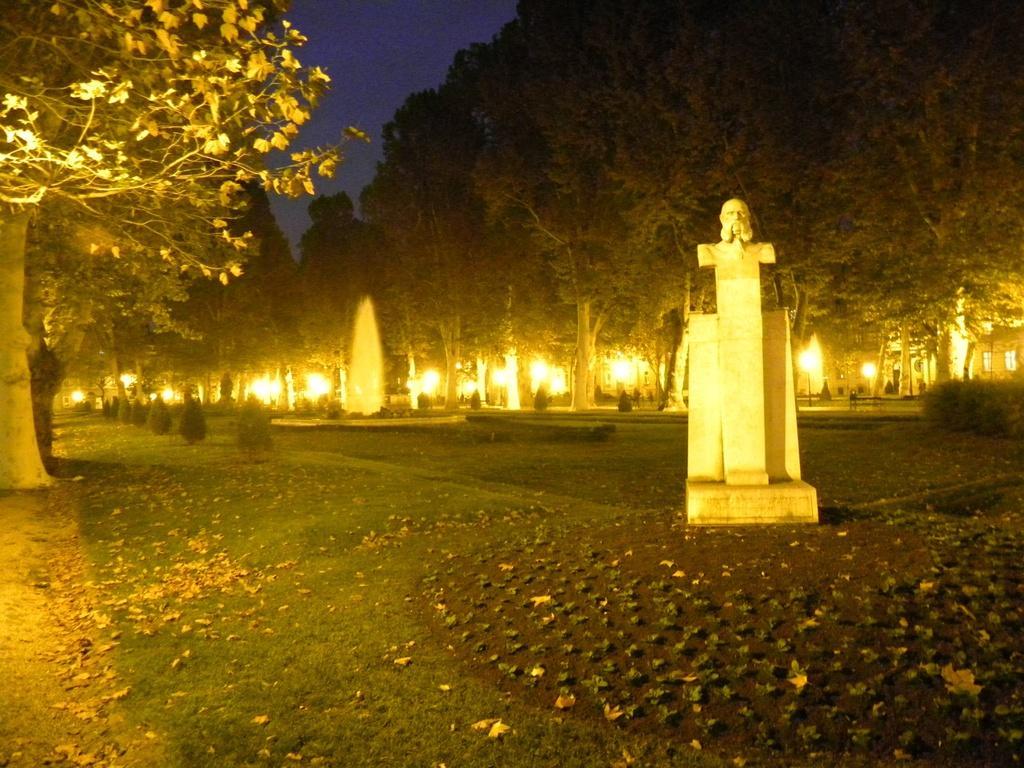Please provide a concise description of this image. This picture is clicked outside. On the right we can see the sculpture of the face of a person and we can see the lights, trees, plants, green grass and the sky and some other objects. 